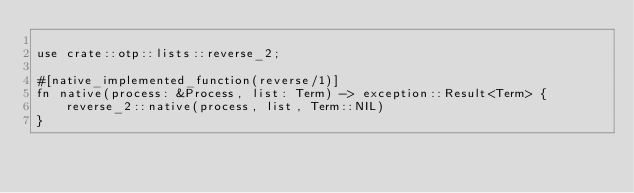Convert code to text. <code><loc_0><loc_0><loc_500><loc_500><_Rust_>
use crate::otp::lists::reverse_2;

#[native_implemented_function(reverse/1)]
fn native(process: &Process, list: Term) -> exception::Result<Term> {
    reverse_2::native(process, list, Term::NIL)
}
</code> 